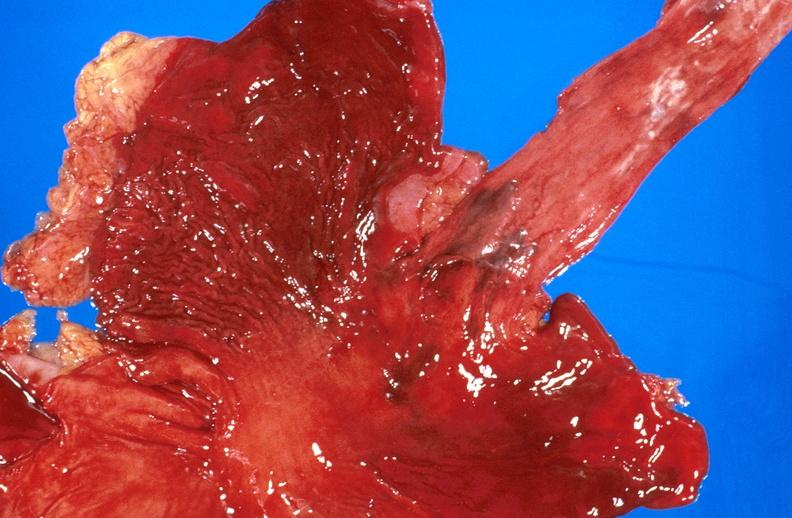does this image show esophageal varices due to alcoholic cirrhosis?
Answer the question using a single word or phrase. Yes 